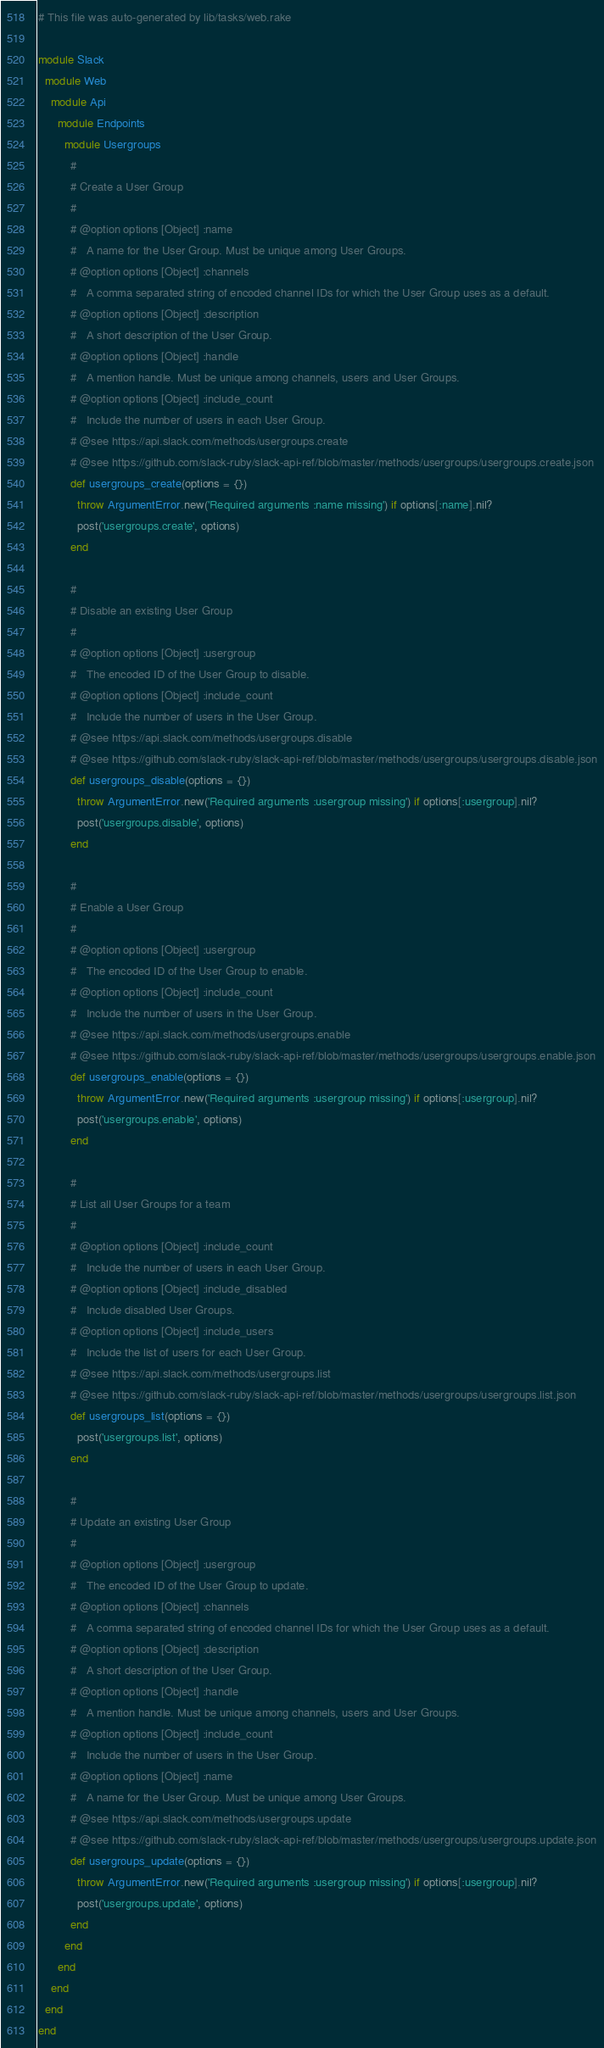<code> <loc_0><loc_0><loc_500><loc_500><_Ruby_># This file was auto-generated by lib/tasks/web.rake

module Slack
  module Web
    module Api
      module Endpoints
        module Usergroups
          #
          # Create a User Group
          #
          # @option options [Object] :name
          #   A name for the User Group. Must be unique among User Groups.
          # @option options [Object] :channels
          #   A comma separated string of encoded channel IDs for which the User Group uses as a default.
          # @option options [Object] :description
          #   A short description of the User Group.
          # @option options [Object] :handle
          #   A mention handle. Must be unique among channels, users and User Groups.
          # @option options [Object] :include_count
          #   Include the number of users in each User Group.
          # @see https://api.slack.com/methods/usergroups.create
          # @see https://github.com/slack-ruby/slack-api-ref/blob/master/methods/usergroups/usergroups.create.json
          def usergroups_create(options = {})
            throw ArgumentError.new('Required arguments :name missing') if options[:name].nil?
            post('usergroups.create', options)
          end

          #
          # Disable an existing User Group
          #
          # @option options [Object] :usergroup
          #   The encoded ID of the User Group to disable.
          # @option options [Object] :include_count
          #   Include the number of users in the User Group.
          # @see https://api.slack.com/methods/usergroups.disable
          # @see https://github.com/slack-ruby/slack-api-ref/blob/master/methods/usergroups/usergroups.disable.json
          def usergroups_disable(options = {})
            throw ArgumentError.new('Required arguments :usergroup missing') if options[:usergroup].nil?
            post('usergroups.disable', options)
          end

          #
          # Enable a User Group
          #
          # @option options [Object] :usergroup
          #   The encoded ID of the User Group to enable.
          # @option options [Object] :include_count
          #   Include the number of users in the User Group.
          # @see https://api.slack.com/methods/usergroups.enable
          # @see https://github.com/slack-ruby/slack-api-ref/blob/master/methods/usergroups/usergroups.enable.json
          def usergroups_enable(options = {})
            throw ArgumentError.new('Required arguments :usergroup missing') if options[:usergroup].nil?
            post('usergroups.enable', options)
          end

          #
          # List all User Groups for a team
          #
          # @option options [Object] :include_count
          #   Include the number of users in each User Group.
          # @option options [Object] :include_disabled
          #   Include disabled User Groups.
          # @option options [Object] :include_users
          #   Include the list of users for each User Group.
          # @see https://api.slack.com/methods/usergroups.list
          # @see https://github.com/slack-ruby/slack-api-ref/blob/master/methods/usergroups/usergroups.list.json
          def usergroups_list(options = {})
            post('usergroups.list', options)
          end

          #
          # Update an existing User Group
          #
          # @option options [Object] :usergroup
          #   The encoded ID of the User Group to update.
          # @option options [Object] :channels
          #   A comma separated string of encoded channel IDs for which the User Group uses as a default.
          # @option options [Object] :description
          #   A short description of the User Group.
          # @option options [Object] :handle
          #   A mention handle. Must be unique among channels, users and User Groups.
          # @option options [Object] :include_count
          #   Include the number of users in the User Group.
          # @option options [Object] :name
          #   A name for the User Group. Must be unique among User Groups.
          # @see https://api.slack.com/methods/usergroups.update
          # @see https://github.com/slack-ruby/slack-api-ref/blob/master/methods/usergroups/usergroups.update.json
          def usergroups_update(options = {})
            throw ArgumentError.new('Required arguments :usergroup missing') if options[:usergroup].nil?
            post('usergroups.update', options)
          end
        end
      end
    end
  end
end
</code> 